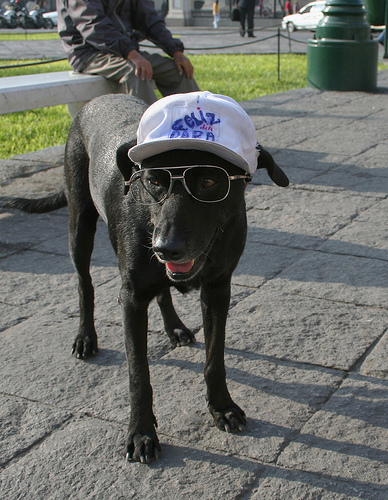Can you imagine what this dog might enjoy doing based on its appearance? Judging by its whimsical outfit, one could imagine this dog enjoys social gatherings, perhaps strutting around a sunny park, engaging with other dogs and people, or even participating in a pet parade, bringing smiles to those around it. 